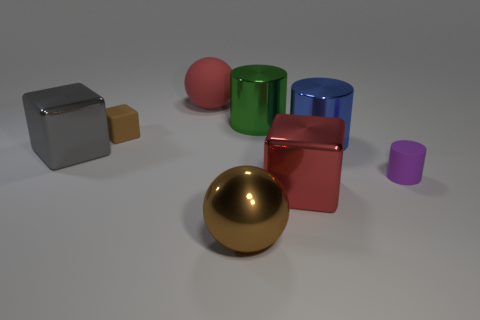There is a metallic thing that is the same color as the large matte object; what is its size?
Provide a succinct answer. Large. Are there any tiny purple cylinders made of the same material as the small purple thing?
Keep it short and to the point. No. Is the number of tiny objects greater than the number of purple rubber things?
Make the answer very short. Yes. Is the material of the green object the same as the large gray cube?
Make the answer very short. Yes. How many matte things are either large red cubes or big green cylinders?
Provide a succinct answer. 0. The matte sphere that is the same size as the green shiny cylinder is what color?
Your response must be concise. Red. What number of tiny brown rubber objects have the same shape as the gray thing?
Keep it short and to the point. 1. What number of balls are either big red rubber objects or big red metallic objects?
Make the answer very short. 1. There is a large red object that is in front of the purple cylinder; does it have the same shape as the small rubber thing to the right of the large red matte thing?
Make the answer very short. No. What is the small brown block made of?
Provide a succinct answer. Rubber. 